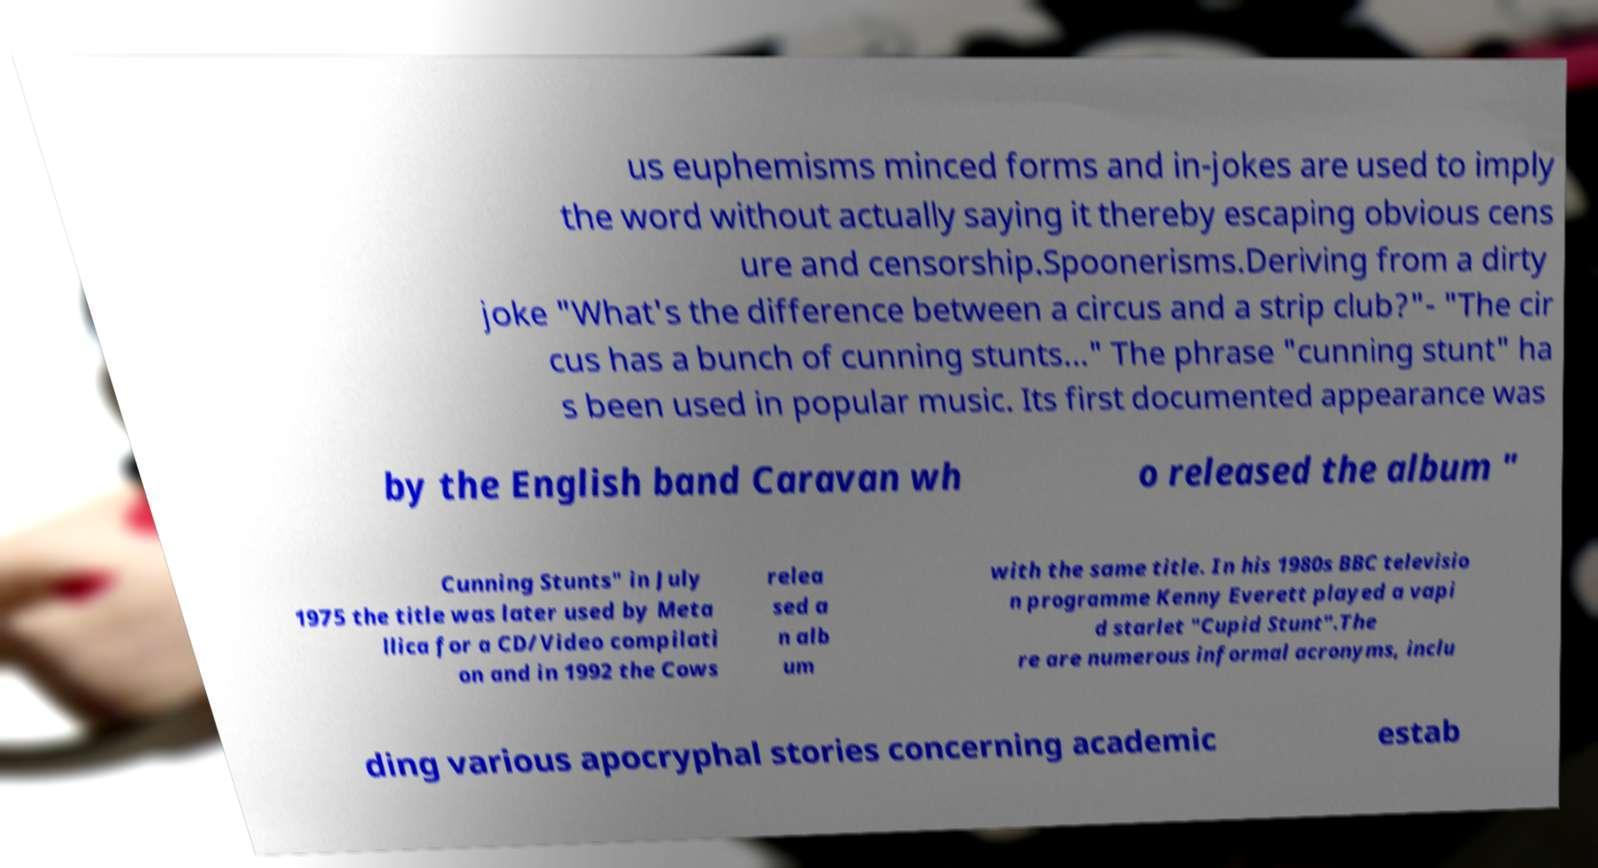Please read and relay the text visible in this image. What does it say? us euphemisms minced forms and in-jokes are used to imply the word without actually saying it thereby escaping obvious cens ure and censorship.Spoonerisms.Deriving from a dirty joke "What's the difference between a circus and a strip club?"- "The cir cus has a bunch of cunning stunts..." The phrase "cunning stunt" ha s been used in popular music. Its first documented appearance was by the English band Caravan wh o released the album " Cunning Stunts" in July 1975 the title was later used by Meta llica for a CD/Video compilati on and in 1992 the Cows relea sed a n alb um with the same title. In his 1980s BBC televisio n programme Kenny Everett played a vapi d starlet "Cupid Stunt".The re are numerous informal acronyms, inclu ding various apocryphal stories concerning academic estab 